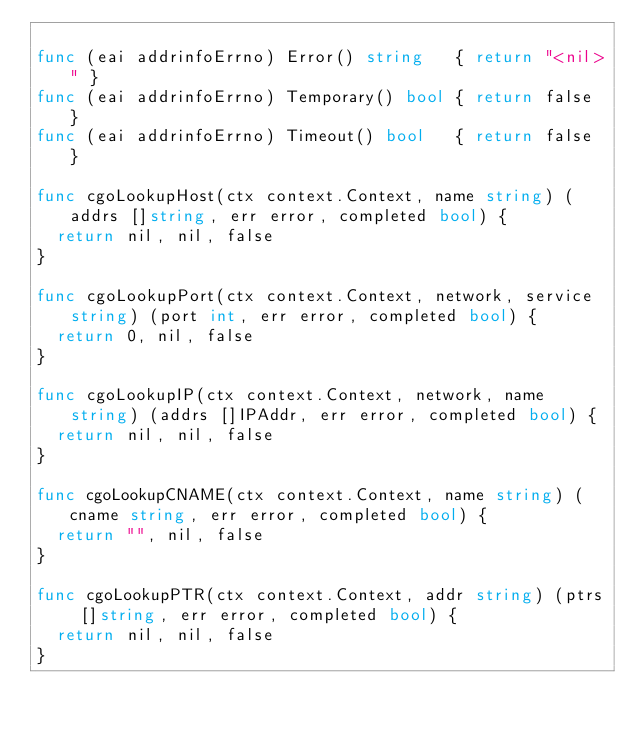<code> <loc_0><loc_0><loc_500><loc_500><_Go_>
func (eai addrinfoErrno) Error() string   { return "<nil>" }
func (eai addrinfoErrno) Temporary() bool { return false }
func (eai addrinfoErrno) Timeout() bool   { return false }

func cgoLookupHost(ctx context.Context, name string) (addrs []string, err error, completed bool) {
	return nil, nil, false
}

func cgoLookupPort(ctx context.Context, network, service string) (port int, err error, completed bool) {
	return 0, nil, false
}

func cgoLookupIP(ctx context.Context, network, name string) (addrs []IPAddr, err error, completed bool) {
	return nil, nil, false
}

func cgoLookupCNAME(ctx context.Context, name string) (cname string, err error, completed bool) {
	return "", nil, false
}

func cgoLookupPTR(ctx context.Context, addr string) (ptrs []string, err error, completed bool) {
	return nil, nil, false
}
</code> 